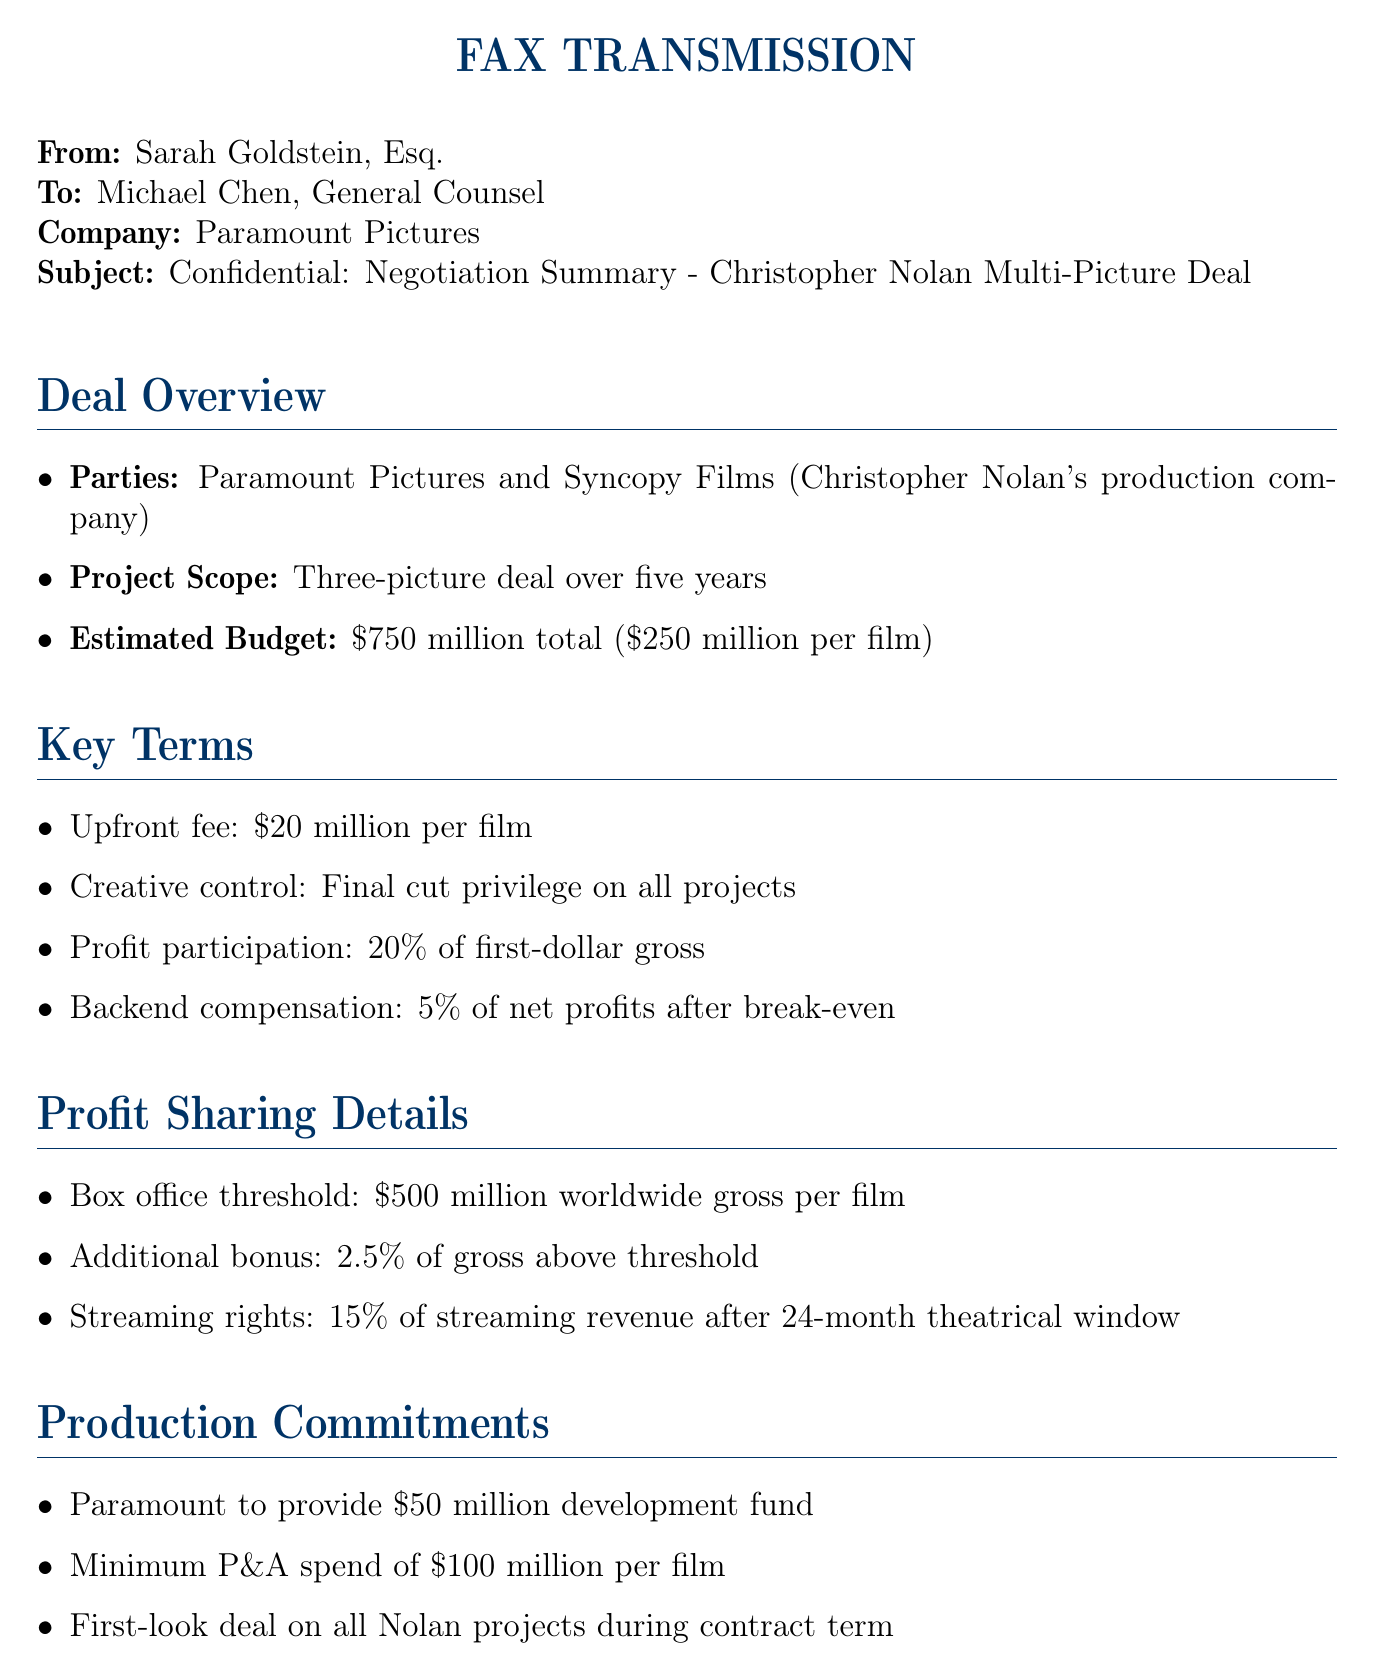What is the name of the director involved in the deal? The director's name is mentioned in relation to his production company, Syncopy Films.
Answer: Christopher Nolan What is the total estimated budget for the three films? The total estimated budget is detailed in the deal overview section.
Answer: $750 million How much is the upfront fee per film? The upfront fee is specified in the key terms section.
Answer: $20 million What percentage of first-dollar gross is the profit participation? The profit participation percentage is listed under the key terms section.
Answer: 20% What is the box office threshold per film for profit sharing? The box office threshold is mentioned in the profit sharing details section.
Answer: $500 million What is the minimum P&A spend per film? The minimum P&A spend requirement is outlined in the production commitments section.
Answer: $100 million By what date should the contract language be finalized? The deadline for finalizing the contract is stated in the next steps section.
Answer: June 15 What is the additional bonus percentage for gross above the threshold? The document specifies an additional bonus for exceeding the box office threshold in the profit sharing details.
Answer: 2.5% What is the confidentiality notice related to? The confidentiality notice mentions restrictions based on a signed agreement.
Answer: NDA signed on May 1, 2023 